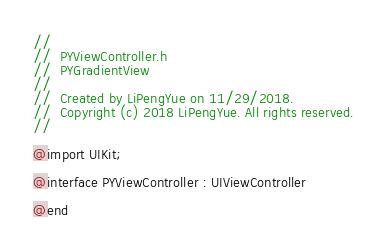Convert code to text. <code><loc_0><loc_0><loc_500><loc_500><_C_>//
//  PYViewController.h
//  PYGradientView
//
//  Created by LiPengYue on 11/29/2018.
//  Copyright (c) 2018 LiPengYue. All rights reserved.
//

@import UIKit;

@interface PYViewController : UIViewController

@end
</code> 